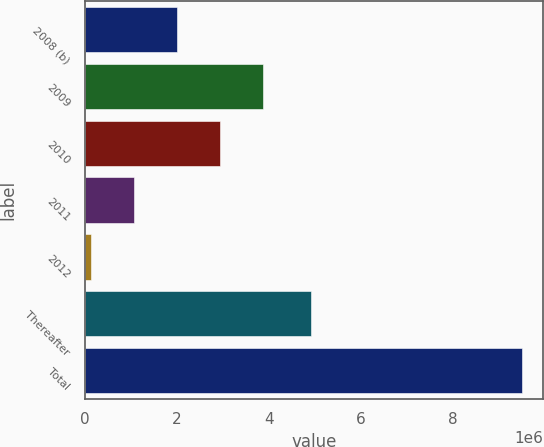<chart> <loc_0><loc_0><loc_500><loc_500><bar_chart><fcel>2008 (b)<fcel>2009<fcel>2010<fcel>2011<fcel>2012<fcel>Thereafter<fcel>Total<nl><fcel>2.00318e+06<fcel>3.87286e+06<fcel>2.93802e+06<fcel>1.06834e+06<fcel>133499<fcel>4.90431e+06<fcel>9.48191e+06<nl></chart> 